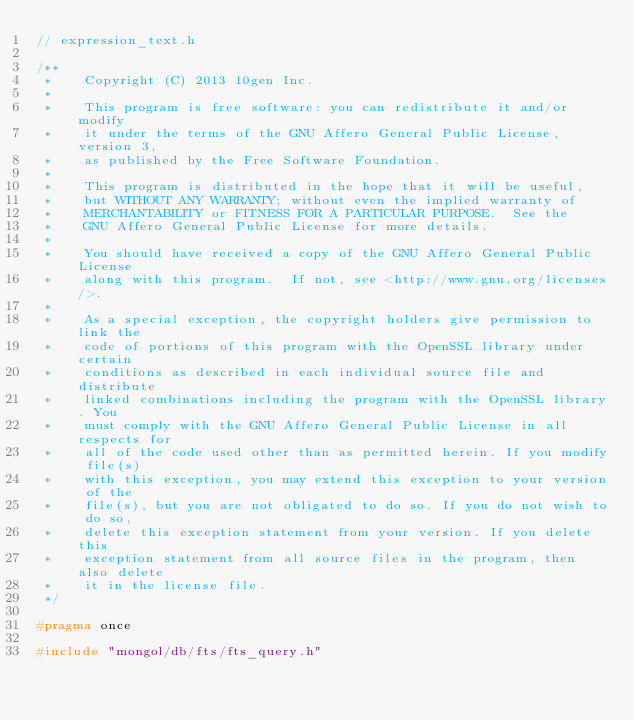<code> <loc_0><loc_0><loc_500><loc_500><_C_>// expression_text.h

/**
 *    Copyright (C) 2013 10gen Inc.
 *
 *    This program is free software: you can redistribute it and/or  modify
 *    it under the terms of the GNU Affero General Public License, version 3,
 *    as published by the Free Software Foundation.
 *
 *    This program is distributed in the hope that it will be useful,
 *    but WITHOUT ANY WARRANTY; without even the implied warranty of
 *    MERCHANTABILITY or FITNESS FOR A PARTICULAR PURPOSE.  See the
 *    GNU Affero General Public License for more details.
 *
 *    You should have received a copy of the GNU Affero General Public License
 *    along with this program.  If not, see <http://www.gnu.org/licenses/>.
 *
 *    As a special exception, the copyright holders give permission to link the
 *    code of portions of this program with the OpenSSL library under certain
 *    conditions as described in each individual source file and distribute
 *    linked combinations including the program with the OpenSSL library. You
 *    must comply with the GNU Affero General Public License in all respects for
 *    all of the code used other than as permitted herein. If you modify file(s)
 *    with this exception, you may extend this exception to your version of the
 *    file(s), but you are not obligated to do so. If you do not wish to do so,
 *    delete this exception statement from your version. If you delete this
 *    exception statement from all source files in the program, then also delete
 *    it in the license file.
 */

#pragma once

#include "mongol/db/fts/fts_query.h"</code> 